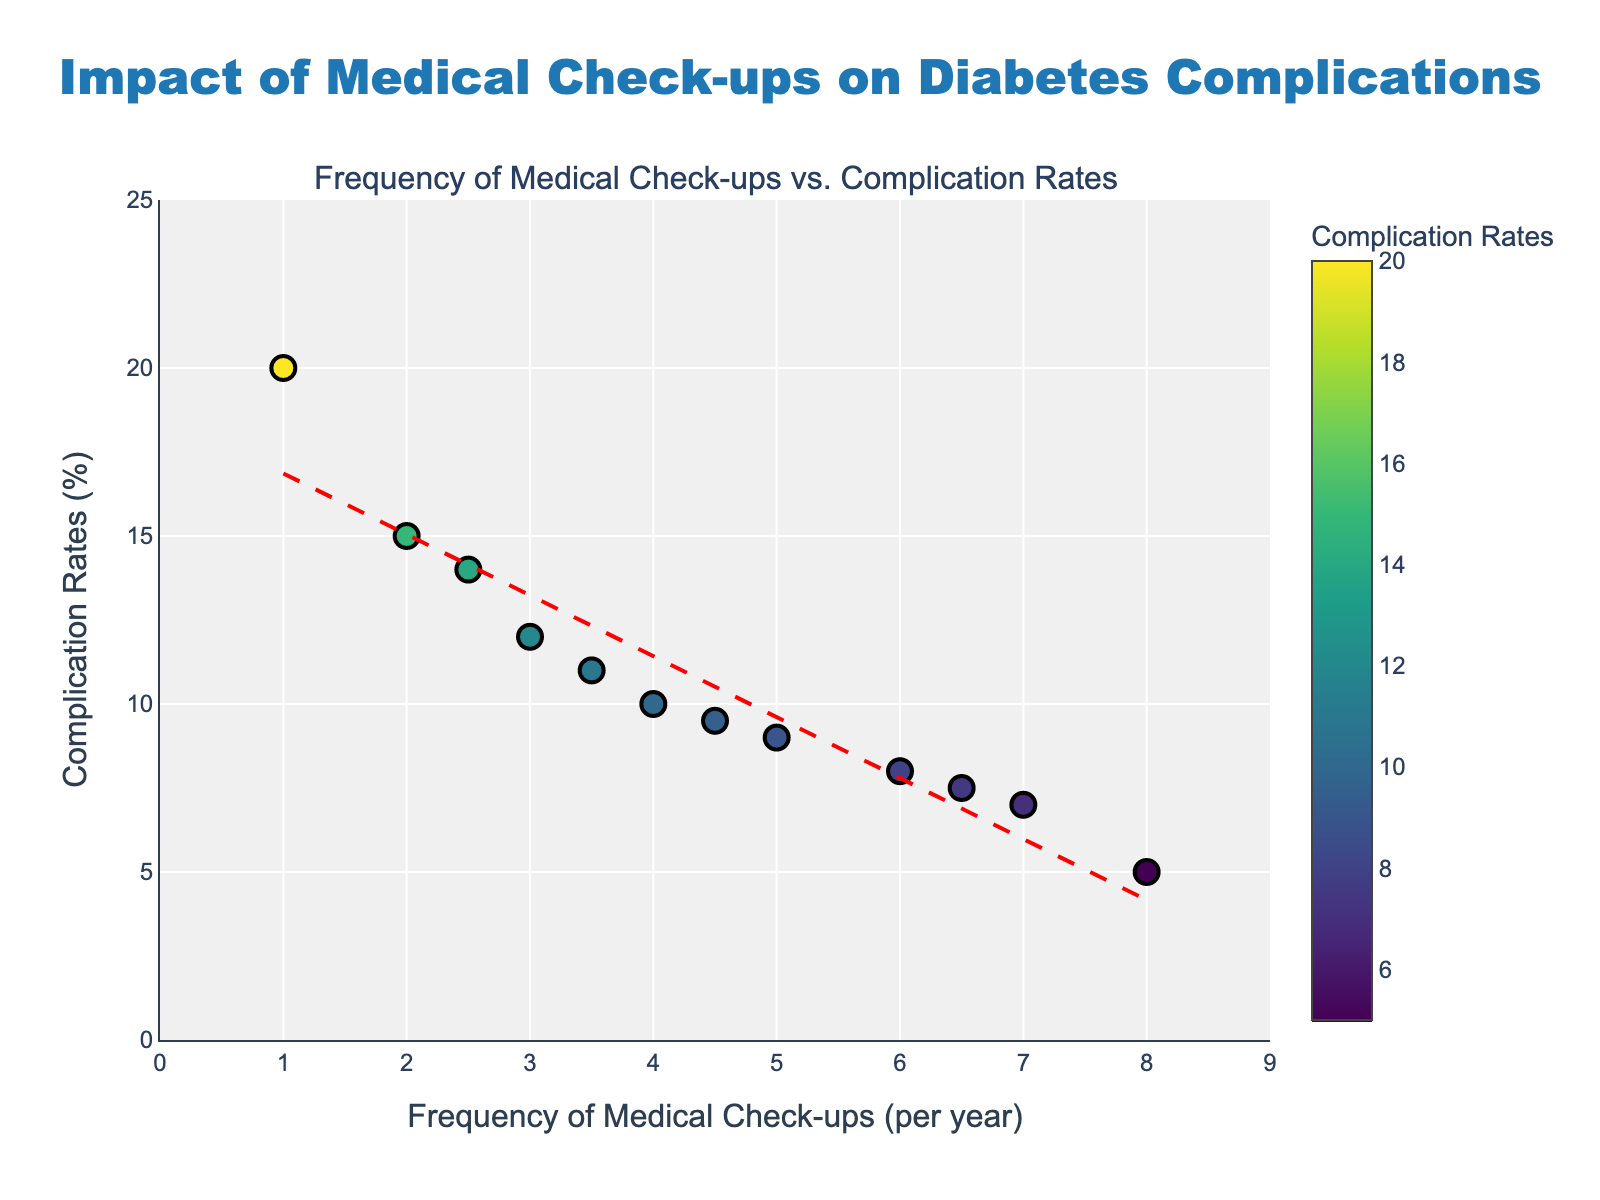What's the title of the figure? The title is displayed at the top of the figure, centered horizontally. It is written in a larger font for emphasis.
Answer: Impact of Medical Check-ups on Diabetes Complications What are the labels of the x-axis and y-axis? The labels are displayed along the horizontal and vertical axes. The x-axis label is below the axis, and the y-axis label is to the left of the axis.
Answer: Frequency of Medical Check-ups (per year) and Complication Rates (%) How many data points are shown in the figure? By counting the markers on the scatter plot, we can determine the total number of data points.
Answer: 12 What is the trend line color in the scatter plot? The trend line color is different from the colorscale markers to stand out. By examining the plot, the trend line is identified by its unique color.
Answer: Red What is the complication rate for 7 medical check-ups? Locate the marker along the x-axis at 7 and then check its corresponding y-value, which is 7. The hover text can also provide this information.
Answer: 7% Which frequency of medical check-ups has the highest complication rate? By looking at the y-values and matching them with their x-values, the highest complication rate corresponds to the largest y-value.
Answer: 1 check-up Which data point shows the lowest complication rate and how many check-ups correspond to it? Identify the data point with the smallest y-value and then check its corresponding x-value.
Answer: 5% at 8 check-ups What's the general trend shown by the trend line? Analyze the slope of the trend line. A negative slope indicates a decrease in complication rates as the frequency of medical check-ups increases.
Answer: Decreasing complication rates as medical check-ups increase calculate the approximate rate of decrease in complication rates per additional medical check-up according to the trend line? The rate of decrease is the slope of the trend line. Since this is a linear trend, it calculates to the change in y-values per unit change in x-values. If the trend line formula given by np.polyfit is y = -2x + 19, the slope (rate of decrease) is -2.
Answer: -2% Which data point deviates the most from the trend line in terms of complication rates? Determine the distance of each point from the trend line. The point with the greatest vertical distance from the line deviates the most. By checking visually, the data point (1, 20) stands out since the expected y-value from the trend line would be significantly lower.
Answer: 1 check-up with a 20% complication rate 